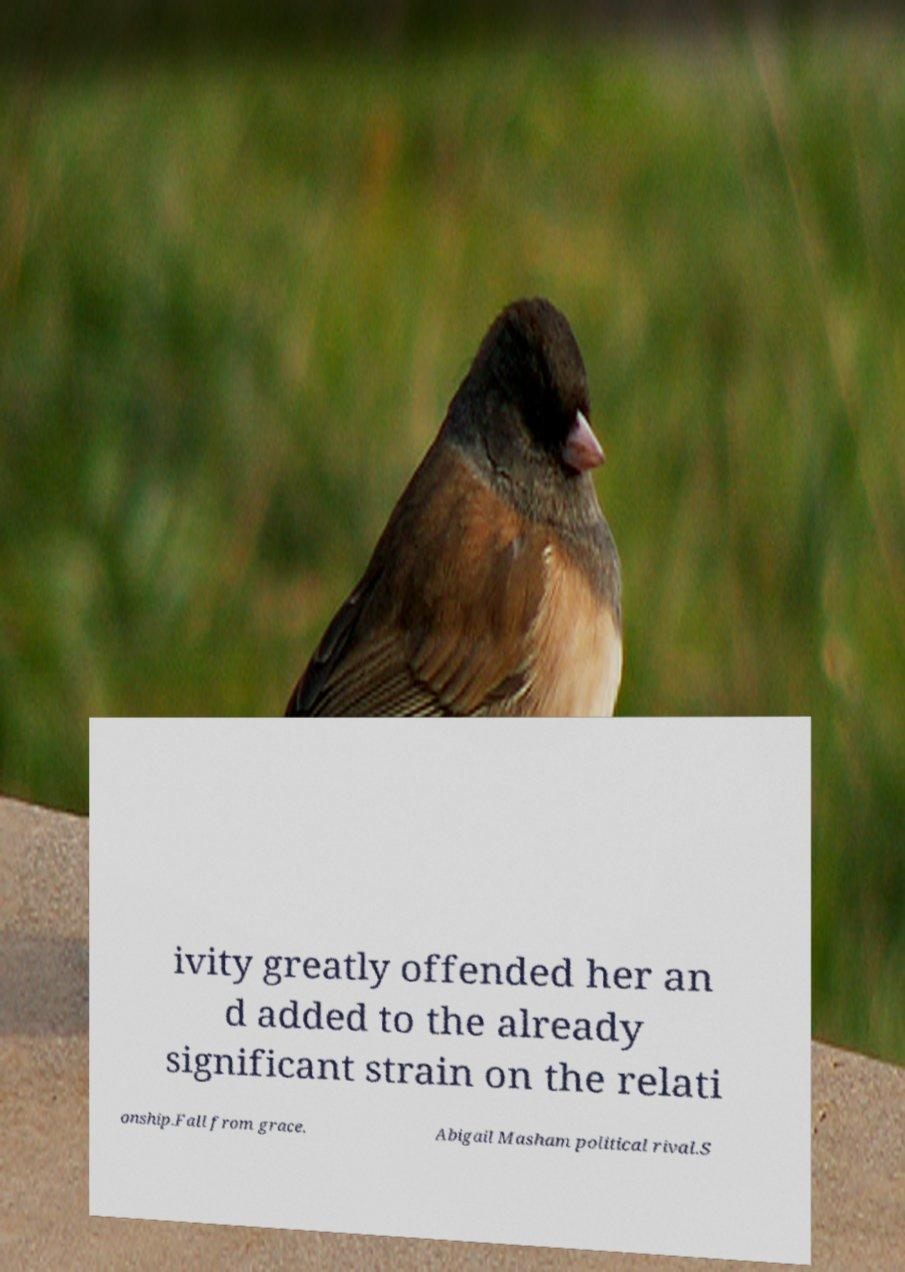I need the written content from this picture converted into text. Can you do that? ivity greatly offended her an d added to the already significant strain on the relati onship.Fall from grace. Abigail Masham political rival.S 